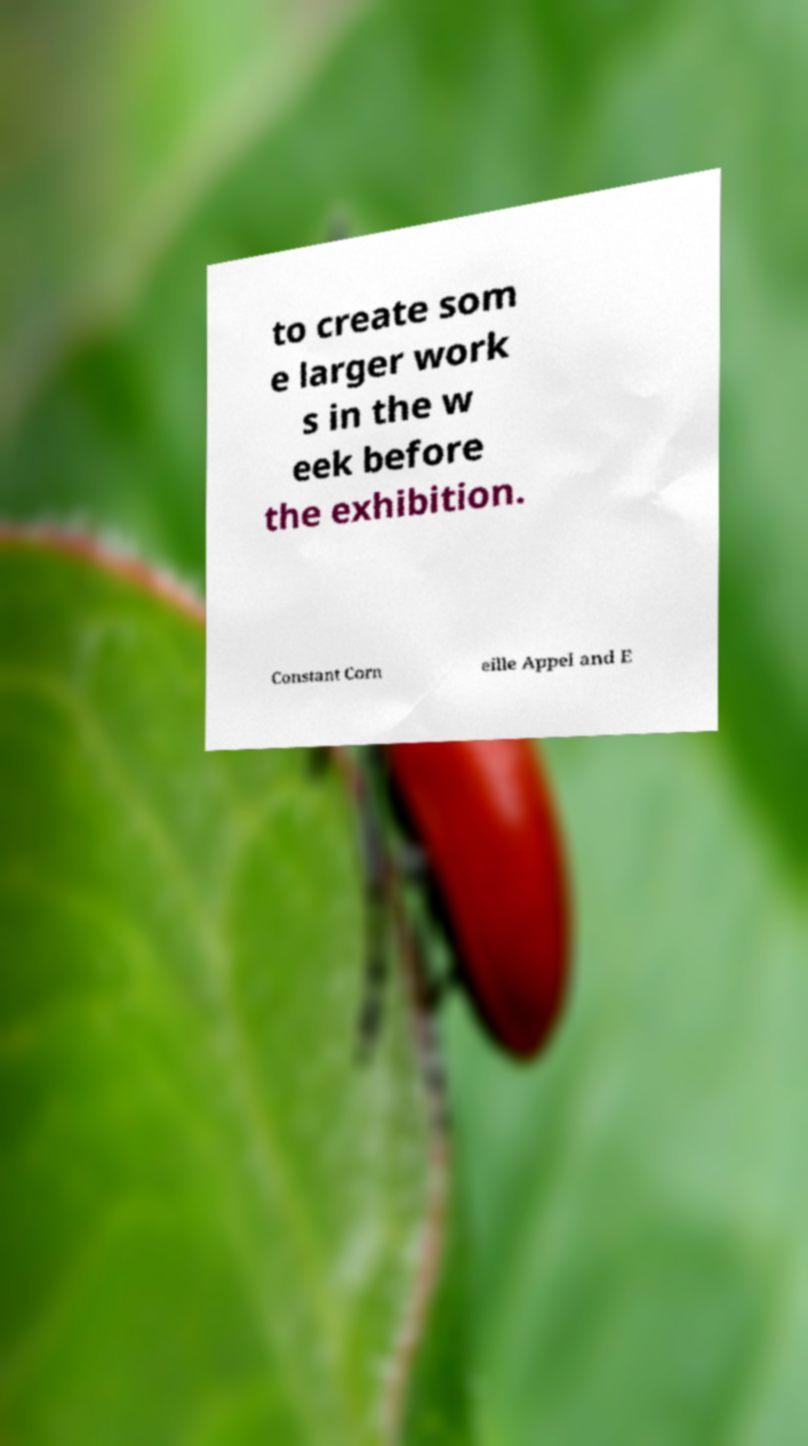There's text embedded in this image that I need extracted. Can you transcribe it verbatim? to create som e larger work s in the w eek before the exhibition. Constant Corn eille Appel and E 